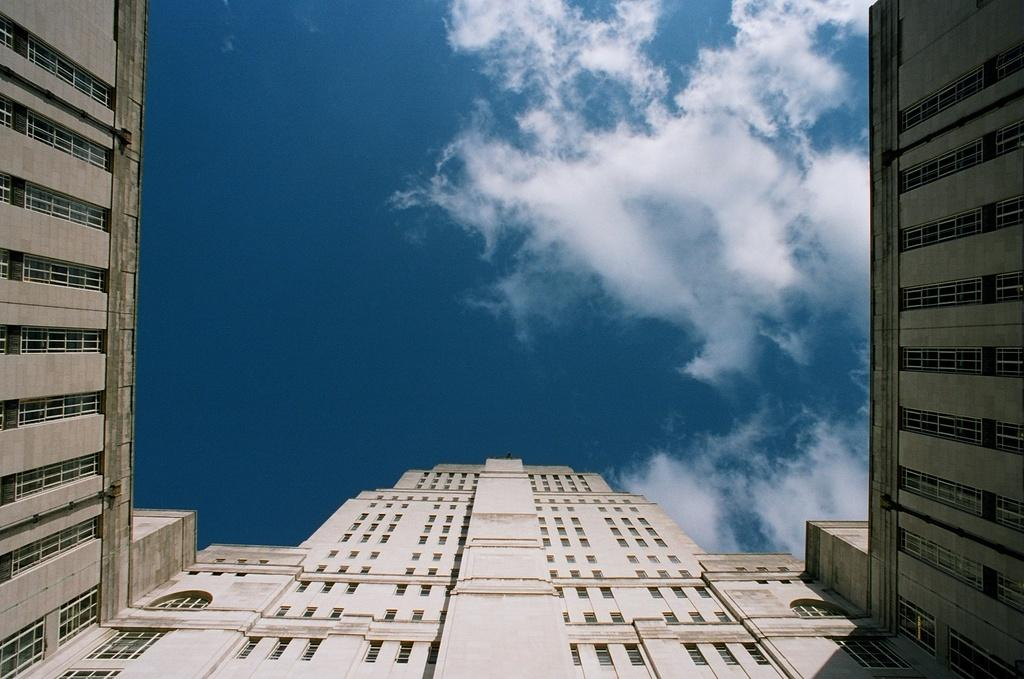What type of structures can be seen in the image? There are buildings in the image. What feature of the buildings is visible in the image? There are windows visible in the image. What part of the natural environment is visible in the image? The sky is visible in the image. What can be observed in the sky? Clouds are present in the sky. What type of linen is draped over the middle building in the image? There is no linen present in the image, and no specific building is mentioned as being in the middle. 